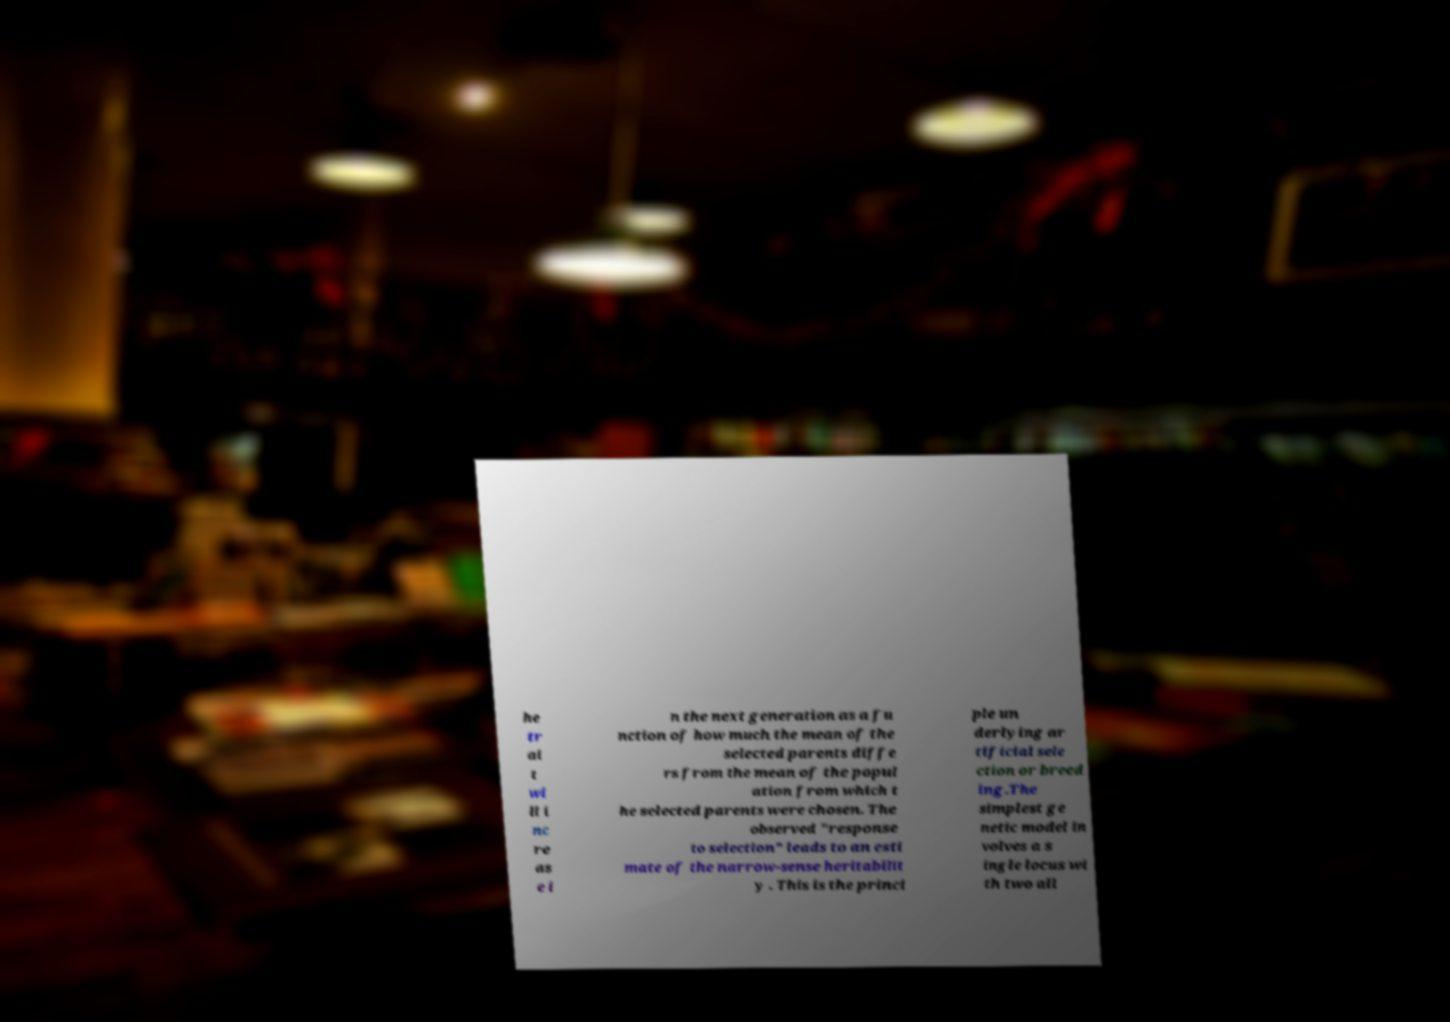There's text embedded in this image that I need extracted. Can you transcribe it verbatim? he tr ai t wi ll i nc re as e i n the next generation as a fu nction of how much the mean of the selected parents diffe rs from the mean of the popul ation from which t he selected parents were chosen. The observed "response to selection" leads to an esti mate of the narrow-sense heritabilit y . This is the princi ple un derlying ar tificial sele ction or breed ing.The simplest ge netic model in volves a s ingle locus wi th two all 